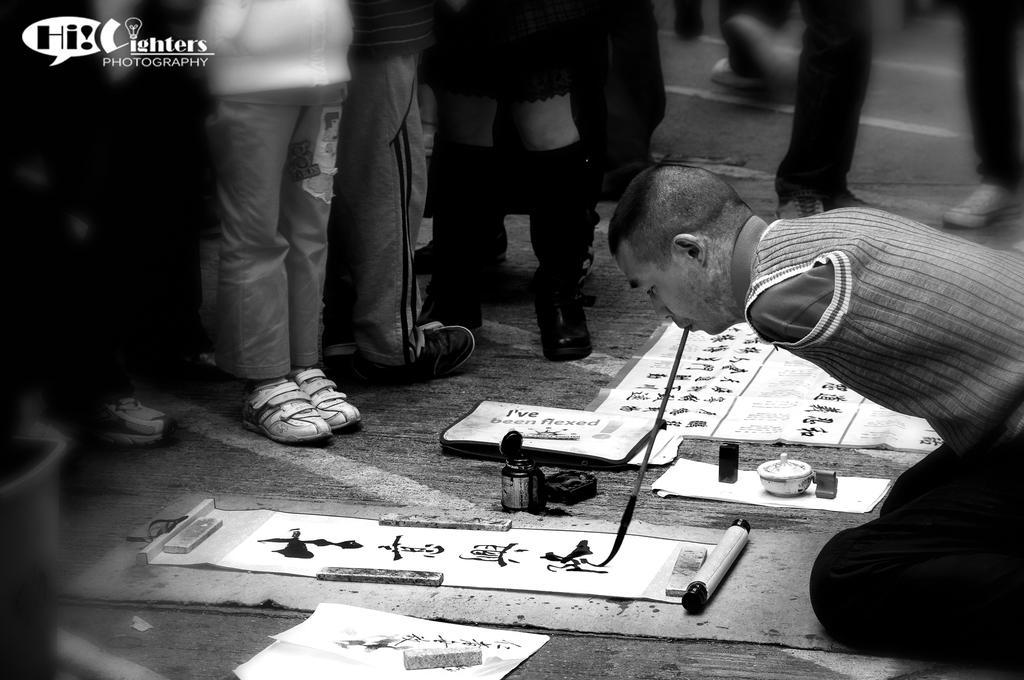How would you summarize this image in a sentence or two? In this image we can see there is a person sitting on his knees and painting with a brush on the paper with the mouth, in front of the person there are a few people standing. 